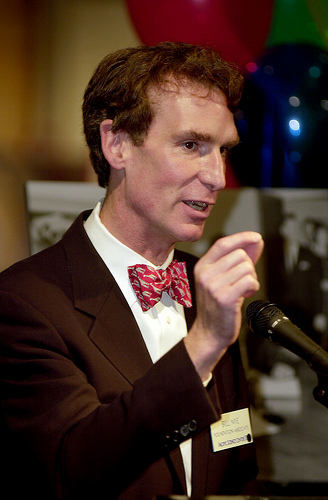<image>Who is this famous person? I don't know who this famous person is. It could possibly be Bill Nye. Who is this famous person? I don't know who this famous person is. It could be Bill Nye, also known as Bill Nye the Science Guy. 